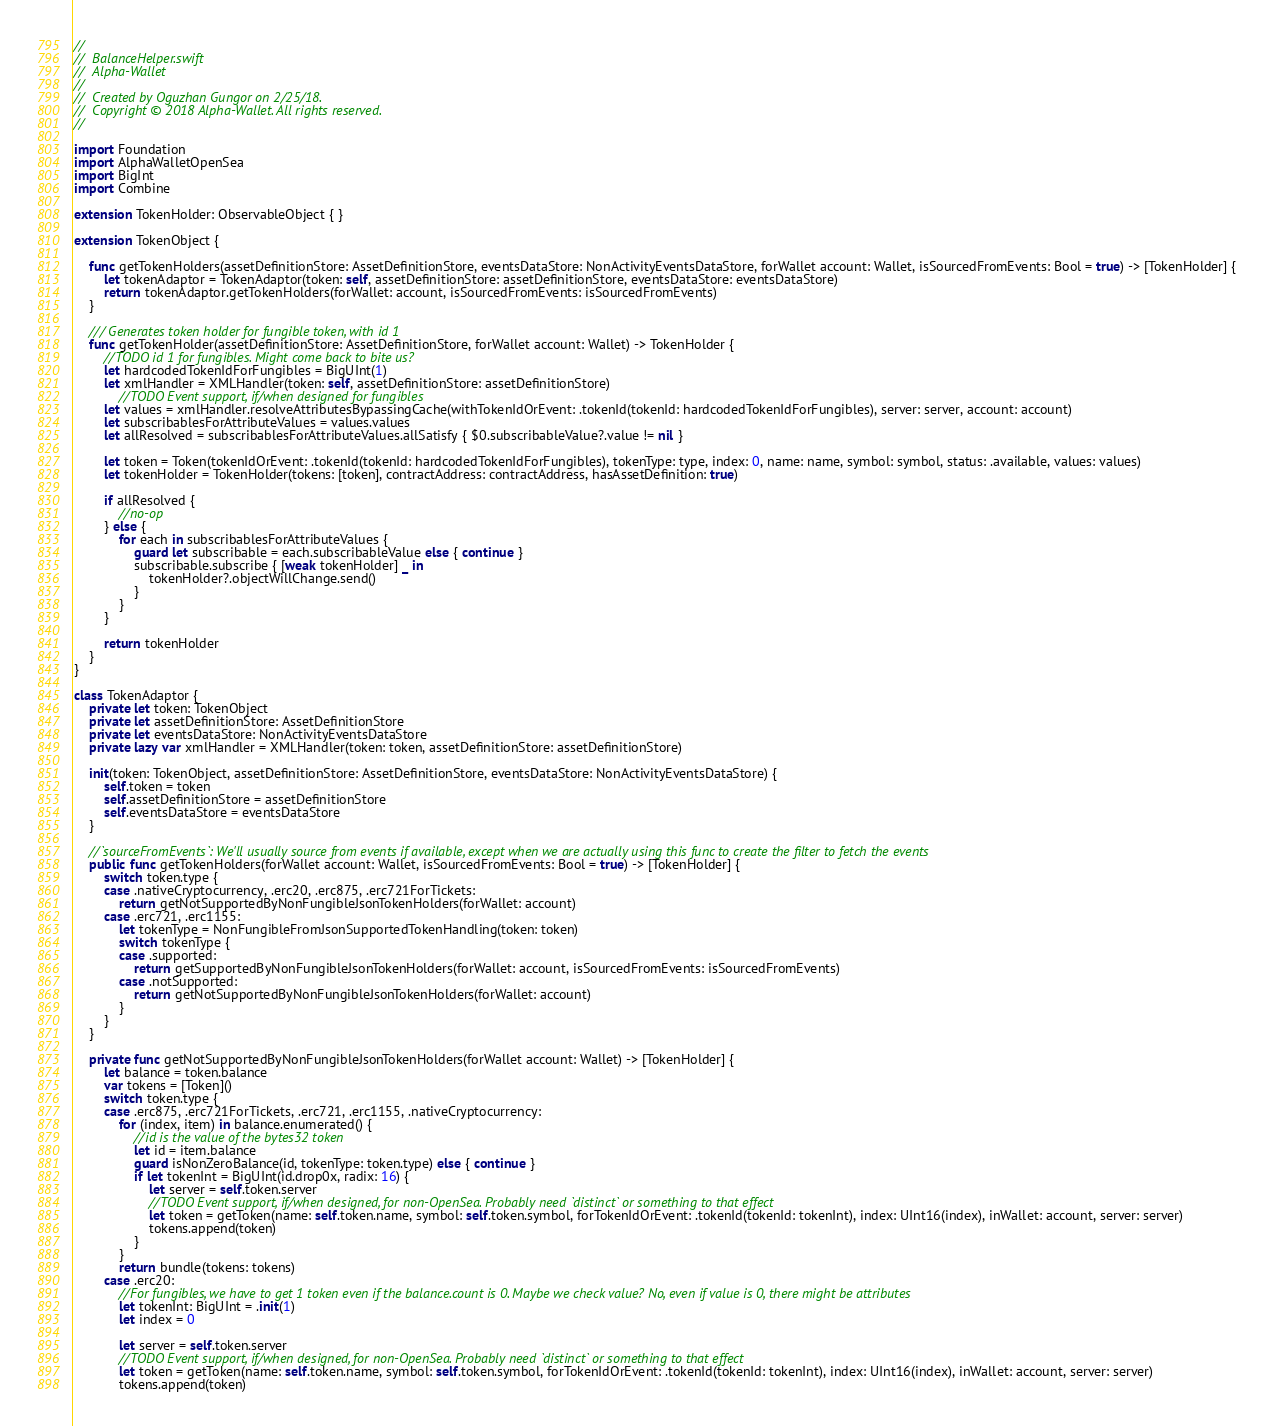Convert code to text. <code><loc_0><loc_0><loc_500><loc_500><_Swift_>//
//  BalanceHelper.swift
//  Alpha-Wallet
//
//  Created by Oguzhan Gungor on 2/25/18.
//  Copyright © 2018 Alpha-Wallet. All rights reserved.
//

import Foundation
import AlphaWalletOpenSea
import BigInt
import Combine

extension TokenHolder: ObservableObject { }

extension TokenObject {

    func getTokenHolders(assetDefinitionStore: AssetDefinitionStore, eventsDataStore: NonActivityEventsDataStore, forWallet account: Wallet, isSourcedFromEvents: Bool = true) -> [TokenHolder] {
        let tokenAdaptor = TokenAdaptor(token: self, assetDefinitionStore: assetDefinitionStore, eventsDataStore: eventsDataStore)
        return tokenAdaptor.getTokenHolders(forWallet: account, isSourcedFromEvents: isSourcedFromEvents)
    }

    /// Generates token holder for fungible token, with id 1
    func getTokenHolder(assetDefinitionStore: AssetDefinitionStore, forWallet account: Wallet) -> TokenHolder {
        //TODO id 1 for fungibles. Might come back to bite us?
        let hardcodedTokenIdForFungibles = BigUInt(1)
        let xmlHandler = XMLHandler(token: self, assetDefinitionStore: assetDefinitionStore)
            //TODO Event support, if/when designed for fungibles
        let values = xmlHandler.resolveAttributesBypassingCache(withTokenIdOrEvent: .tokenId(tokenId: hardcodedTokenIdForFungibles), server: server, account: account)
        let subscribablesForAttributeValues = values.values
        let allResolved = subscribablesForAttributeValues.allSatisfy { $0.subscribableValue?.value != nil }

        let token = Token(tokenIdOrEvent: .tokenId(tokenId: hardcodedTokenIdForFungibles), tokenType: type, index: 0, name: name, symbol: symbol, status: .available, values: values)
        let tokenHolder = TokenHolder(tokens: [token], contractAddress: contractAddress, hasAssetDefinition: true)

        if allResolved {
            //no-op
        } else {
            for each in subscribablesForAttributeValues {
                guard let subscribable = each.subscribableValue else { continue }
                subscribable.subscribe { [weak tokenHolder] _ in
                    tokenHolder?.objectWillChange.send()
                }
            }
        }

        return tokenHolder
    }
}

class TokenAdaptor {
    private let token: TokenObject
    private let assetDefinitionStore: AssetDefinitionStore
    private let eventsDataStore: NonActivityEventsDataStore
    private lazy var xmlHandler = XMLHandler(token: token, assetDefinitionStore: assetDefinitionStore)

    init(token: TokenObject, assetDefinitionStore: AssetDefinitionStore, eventsDataStore: NonActivityEventsDataStore) {
        self.token = token
        self.assetDefinitionStore = assetDefinitionStore
        self.eventsDataStore = eventsDataStore
    }

    //`sourceFromEvents`: We'll usually source from events if available, except when we are actually using this func to create the filter to fetch the events
    public func getTokenHolders(forWallet account: Wallet, isSourcedFromEvents: Bool = true) -> [TokenHolder] {
        switch token.type {
        case .nativeCryptocurrency, .erc20, .erc875, .erc721ForTickets:
            return getNotSupportedByNonFungibleJsonTokenHolders(forWallet: account)
        case .erc721, .erc1155:
            let tokenType = NonFungibleFromJsonSupportedTokenHandling(token: token)
            switch tokenType {
            case .supported:
                return getSupportedByNonFungibleJsonTokenHolders(forWallet: account, isSourcedFromEvents: isSourcedFromEvents)
            case .notSupported:
                return getNotSupportedByNonFungibleJsonTokenHolders(forWallet: account)
            }
        }
    }

    private func getNotSupportedByNonFungibleJsonTokenHolders(forWallet account: Wallet) -> [TokenHolder] {
        let balance = token.balance
        var tokens = [Token]()
        switch token.type {
        case .erc875, .erc721ForTickets, .erc721, .erc1155, .nativeCryptocurrency:
            for (index, item) in balance.enumerated() {
                //id is the value of the bytes32 token
                let id = item.balance
                guard isNonZeroBalance(id, tokenType: token.type) else { continue }
                if let tokenInt = BigUInt(id.drop0x, radix: 16) {
                    let server = self.token.server
                    //TODO Event support, if/when designed, for non-OpenSea. Probably need `distinct` or something to that effect
                    let token = getToken(name: self.token.name, symbol: self.token.symbol, forTokenIdOrEvent: .tokenId(tokenId: tokenInt), index: UInt16(index), inWallet: account, server: server)
                    tokens.append(token)
                }
            }
            return bundle(tokens: tokens)
        case .erc20:
            //For fungibles, we have to get 1 token even if the balance.count is 0. Maybe we check value? No, even if value is 0, there might be attributes
            let tokenInt: BigUInt = .init(1)
            let index = 0

            let server = self.token.server
            //TODO Event support, if/when designed, for non-OpenSea. Probably need `distinct` or something to that effect
            let token = getToken(name: self.token.name, symbol: self.token.symbol, forTokenIdOrEvent: .tokenId(tokenId: tokenInt), index: UInt16(index), inWallet: account, server: server)
            tokens.append(token)</code> 